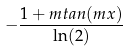<formula> <loc_0><loc_0><loc_500><loc_500>- \frac { 1 + m t a n ( m x ) } { \ln ( 2 ) }</formula> 